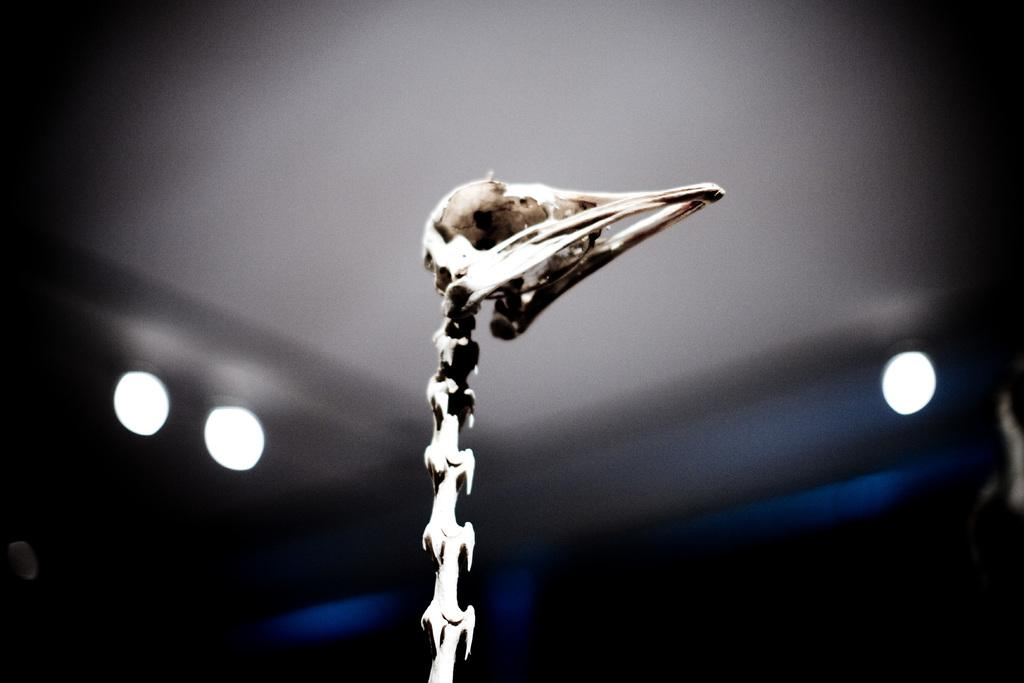What is the main subject in the center of the image? There is a skull in the center of the image. What can be seen in the background of the image? There are lights and a wall in the background of the image. Can you tell me how many nerves are connected to the skull in the image? There is no indication of nerves connected to the skull in the image; it is a representation of a skull without any biological context. 